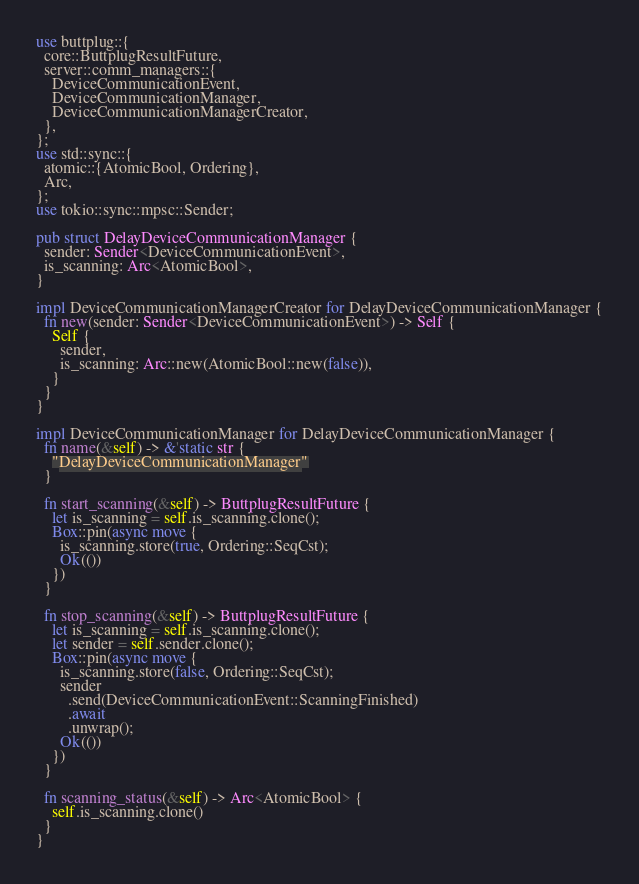<code> <loc_0><loc_0><loc_500><loc_500><_Rust_>use buttplug::{
  core::ButtplugResultFuture,
  server::comm_managers::{
    DeviceCommunicationEvent,
    DeviceCommunicationManager,
    DeviceCommunicationManagerCreator,
  },
};
use std::sync::{
  atomic::{AtomicBool, Ordering},
  Arc,
};
use tokio::sync::mpsc::Sender;

pub struct DelayDeviceCommunicationManager {
  sender: Sender<DeviceCommunicationEvent>,
  is_scanning: Arc<AtomicBool>,
}

impl DeviceCommunicationManagerCreator for DelayDeviceCommunicationManager {
  fn new(sender: Sender<DeviceCommunicationEvent>) -> Self {
    Self {
      sender,
      is_scanning: Arc::new(AtomicBool::new(false)),
    }
  }
}

impl DeviceCommunicationManager for DelayDeviceCommunicationManager {
  fn name(&self) -> &'static str {
    "DelayDeviceCommunicationManager"
  }

  fn start_scanning(&self) -> ButtplugResultFuture {
    let is_scanning = self.is_scanning.clone();
    Box::pin(async move {
      is_scanning.store(true, Ordering::SeqCst);
      Ok(())
    })
  }

  fn stop_scanning(&self) -> ButtplugResultFuture {
    let is_scanning = self.is_scanning.clone();
    let sender = self.sender.clone();
    Box::pin(async move {
      is_scanning.store(false, Ordering::SeqCst);
      sender
        .send(DeviceCommunicationEvent::ScanningFinished)
        .await
        .unwrap();
      Ok(())
    })
  }

  fn scanning_status(&self) -> Arc<AtomicBool> {
    self.is_scanning.clone()
  }
}
</code> 